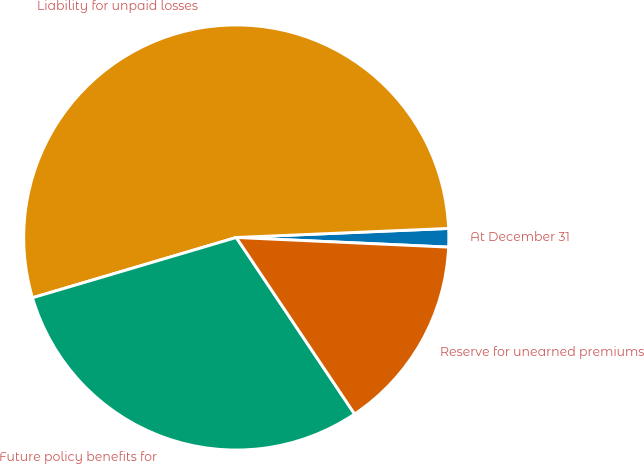Convert chart to OTSL. <chart><loc_0><loc_0><loc_500><loc_500><pie_chart><fcel>At December 31<fcel>Liability for unpaid losses<fcel>Future policy benefits for<fcel>Reserve for unearned premiums<nl><fcel>1.4%<fcel>53.9%<fcel>29.82%<fcel>14.88%<nl></chart> 